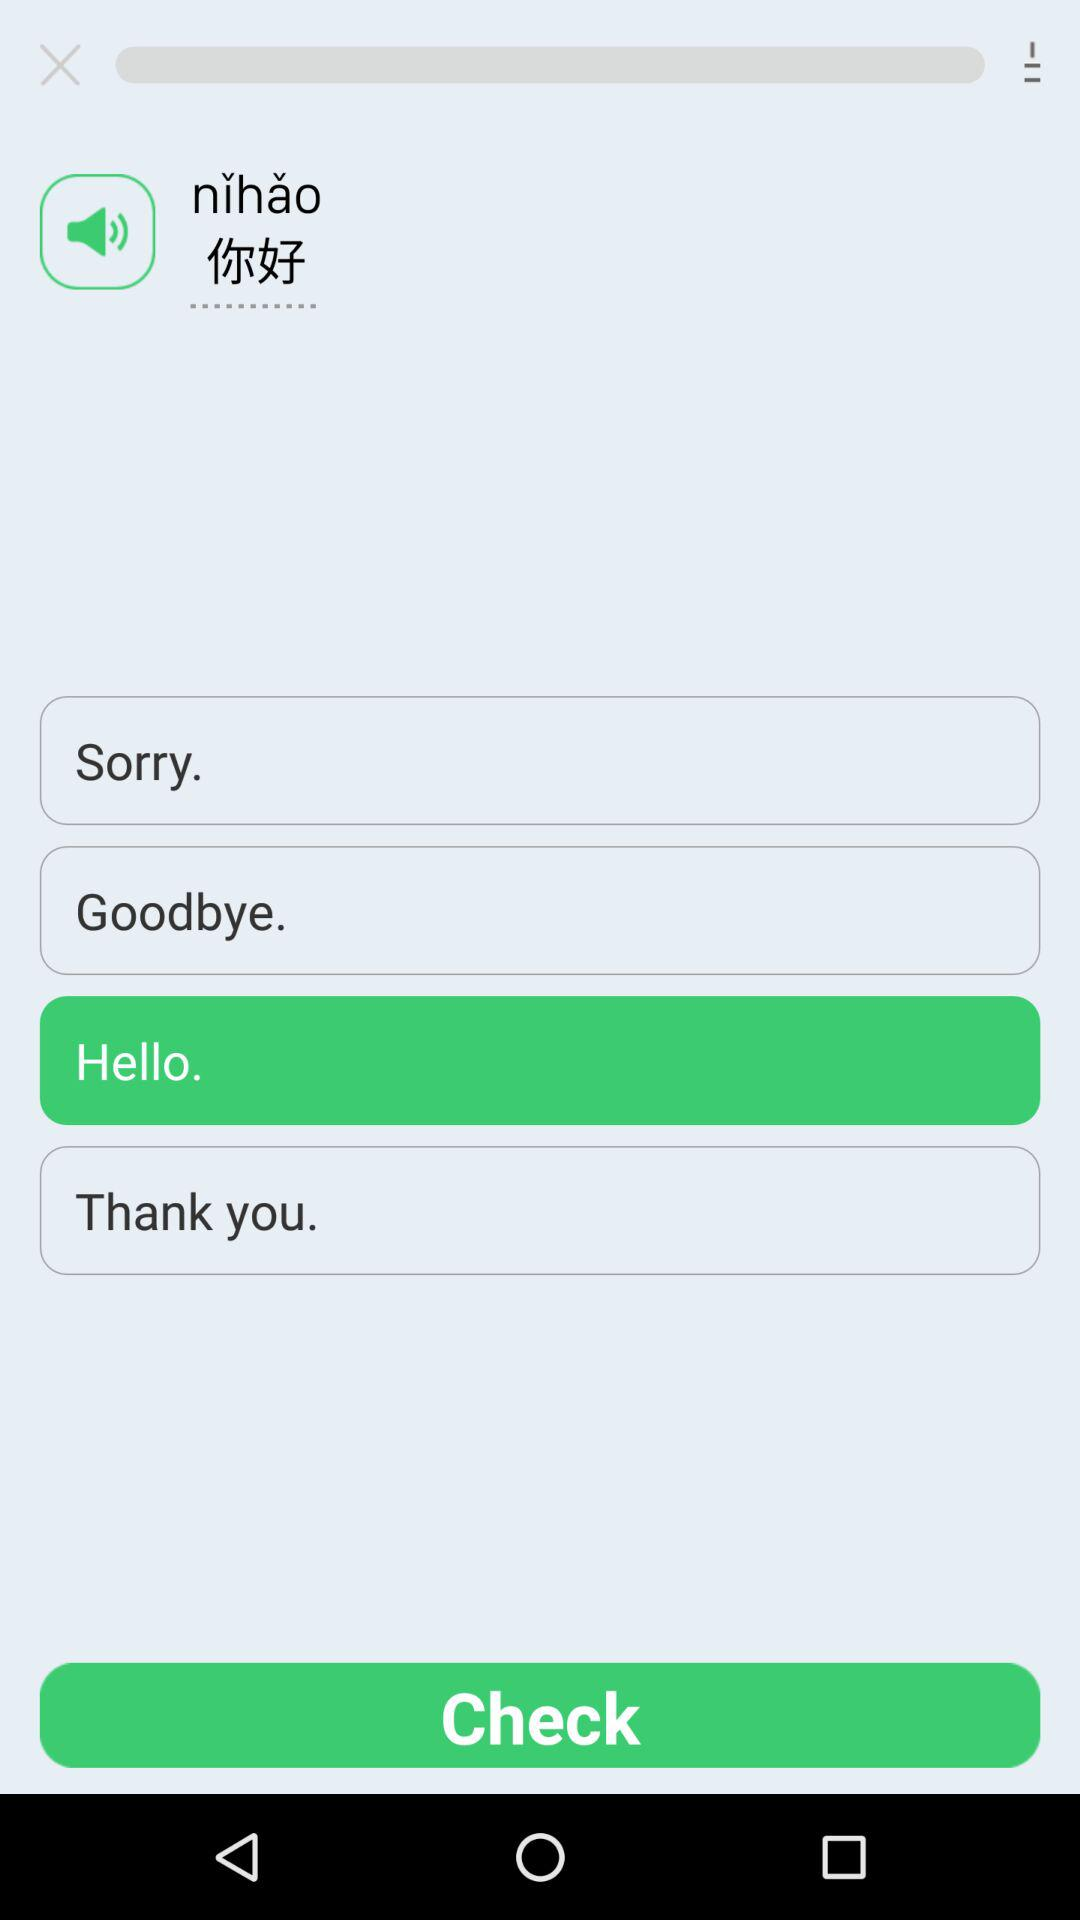What is the meaning of the nihao?
When the provided information is insufficient, respond with <no answer>. <no answer> 